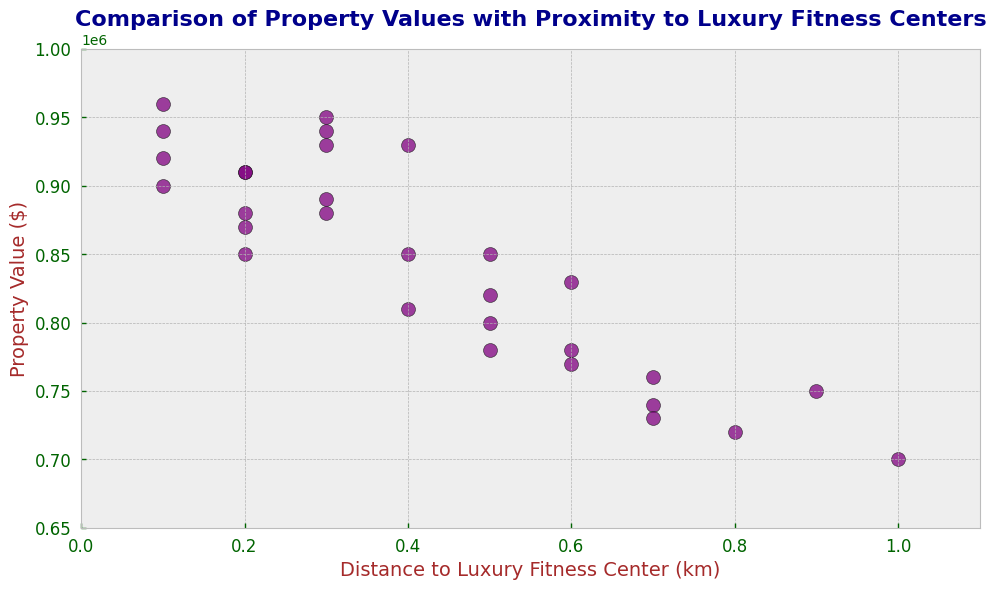Which property is located closest to a luxury fitness center and what is its value? The scatter plot can be inspected for the data point with the smallest distance to a luxury fitness center. From the plot, the property with a distance of 0.1 km is closest. The corresponding property values are 920,000, 940,000, and 960,000 dollars.
Answer: 920,000, 940,000, and 960,000 What is the general trend observed in property values as the distance to luxury fitness centers increases? By observing the scatter plot, it can be seen that as the distance to luxury fitness centers increases, the general trend shows that property values tend to decrease.
Answer: Property values decrease How many properties are valued above 900,000 dollars and within 0.3 km of a luxury fitness center? To determine this, locate the points that are both above 900,000 dollars on the y-axis and within 0.3 km on the x-axis. The properties fitting these criteria are located at (0.1, 920000), (0.1, 940000), (0.1, 960000), (0.2, 910000), (0.2, 940000), (0.3, 950000), and (0.3, 880000).
Answer: 7 What is the highest property value, and what is the distance to the nearest luxury fitness center for that property? By referencing the highest point on the y-axis (property value), the corresponding data point is at (0.1, 960000). The distance to the nearest luxury fitness center for this property is 0.1 km.
Answer: 960,000 dollars and 0.1 km What is the average property value of the properties within 0.4 km distance from a luxury fitness center? Locate all the points up to 0.4 km on the x-axis and sum their values: 920,000 + 940,000 + 960,000 + 850,000 + 870,000 + 910,000 + 940,000 + 880,000 + 930,000 + 850,000 + 950,000 + 880,000 + 930,000 + 900,000. Divide the sum by the number of properties (14). (14,500,000 / 14).
Answer: 870,000 dollars Do properties become more variable in value as the distance to a luxury fitness center increases? Inspect the scatter plot for the spread (variability) of property values at different distance intervals. Visually, the values seem to be more tightly clustered at closer distances and spread out more at distances larger than 0.5 km.
Answer: Yes 